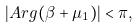<formula> <loc_0><loc_0><loc_500><loc_500>| A r g ( \beta + \mu _ { 1 } ) | < \pi ,</formula> 